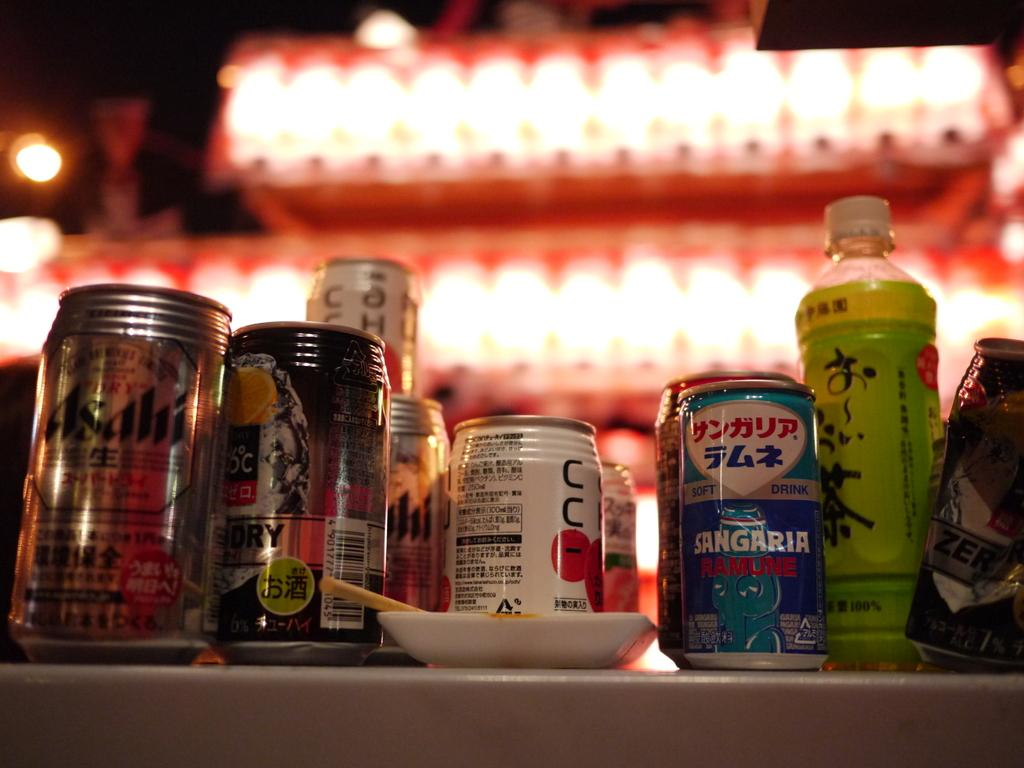<image>
Relay a brief, clear account of the picture shown. a can of sangaria sits next to several other cans and bottles 